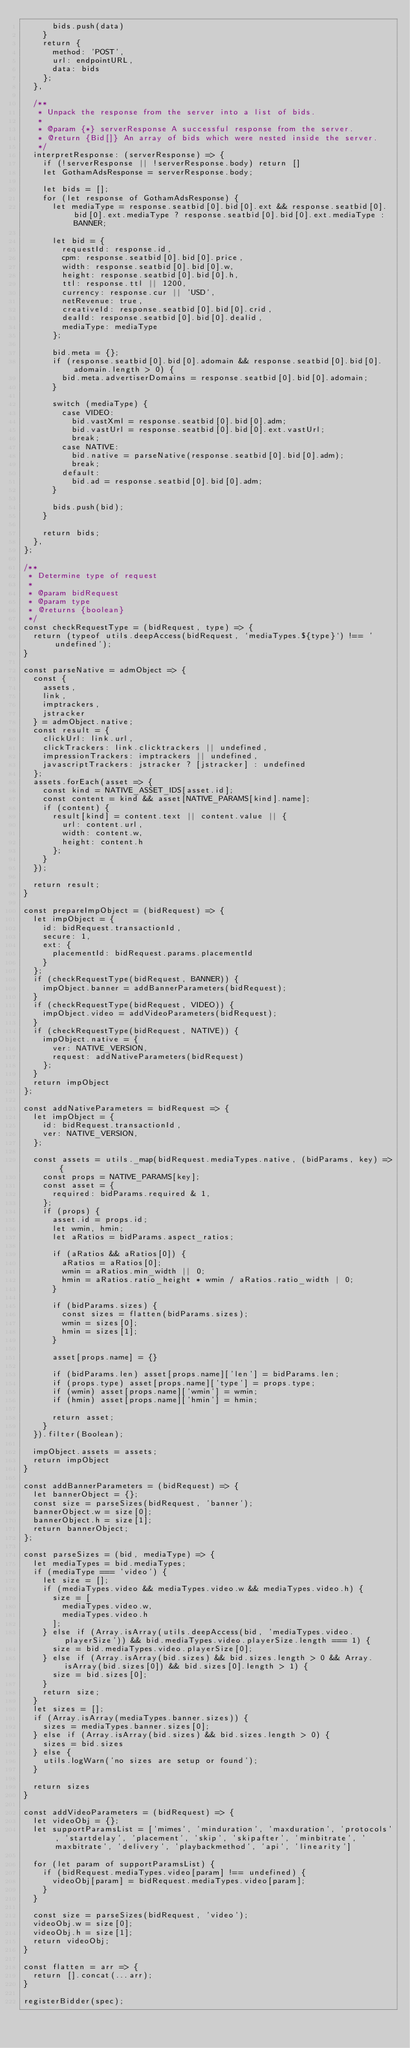Convert code to text. <code><loc_0><loc_0><loc_500><loc_500><_JavaScript_>      bids.push(data)
    }
    return {
      method: 'POST',
      url: endpointURL,
      data: bids
    };
  },

  /**
   * Unpack the response from the server into a list of bids.
   *
   * @param {*} serverResponse A successful response from the server.
   * @return {Bid[]} An array of bids which were nested inside the server.
   */
  interpretResponse: (serverResponse) => {
    if (!serverResponse || !serverResponse.body) return []
    let GothamAdsResponse = serverResponse.body;

    let bids = [];
    for (let response of GothamAdsResponse) {
      let mediaType = response.seatbid[0].bid[0].ext && response.seatbid[0].bid[0].ext.mediaType ? response.seatbid[0].bid[0].ext.mediaType : BANNER;

      let bid = {
        requestId: response.id,
        cpm: response.seatbid[0].bid[0].price,
        width: response.seatbid[0].bid[0].w,
        height: response.seatbid[0].bid[0].h,
        ttl: response.ttl || 1200,
        currency: response.cur || 'USD',
        netRevenue: true,
        creativeId: response.seatbid[0].bid[0].crid,
        dealId: response.seatbid[0].bid[0].dealid,
        mediaType: mediaType
      };

      bid.meta = {};
      if (response.seatbid[0].bid[0].adomain && response.seatbid[0].bid[0].adomain.length > 0) {
        bid.meta.advertiserDomains = response.seatbid[0].bid[0].adomain;
      }

      switch (mediaType) {
        case VIDEO:
          bid.vastXml = response.seatbid[0].bid[0].adm;
          bid.vastUrl = response.seatbid[0].bid[0].ext.vastUrl;
          break;
        case NATIVE:
          bid.native = parseNative(response.seatbid[0].bid[0].adm);
          break;
        default:
          bid.ad = response.seatbid[0].bid[0].adm;
      }

      bids.push(bid);
    }

    return bids;
  },
};

/**
 * Determine type of request
 *
 * @param bidRequest
 * @param type
 * @returns {boolean}
 */
const checkRequestType = (bidRequest, type) => {
  return (typeof utils.deepAccess(bidRequest, `mediaTypes.${type}`) !== 'undefined');
}

const parseNative = admObject => {
  const {
    assets,
    link,
    imptrackers,
    jstracker
  } = admObject.native;
  const result = {
    clickUrl: link.url,
    clickTrackers: link.clicktrackers || undefined,
    impressionTrackers: imptrackers || undefined,
    javascriptTrackers: jstracker ? [jstracker] : undefined
  };
  assets.forEach(asset => {
    const kind = NATIVE_ASSET_IDS[asset.id];
    const content = kind && asset[NATIVE_PARAMS[kind].name];
    if (content) {
      result[kind] = content.text || content.value || {
        url: content.url,
        width: content.w,
        height: content.h
      };
    }
  });

  return result;
}

const prepareImpObject = (bidRequest) => {
  let impObject = {
    id: bidRequest.transactionId,
    secure: 1,
    ext: {
      placementId: bidRequest.params.placementId
    }
  };
  if (checkRequestType(bidRequest, BANNER)) {
    impObject.banner = addBannerParameters(bidRequest);
  }
  if (checkRequestType(bidRequest, VIDEO)) {
    impObject.video = addVideoParameters(bidRequest);
  }
  if (checkRequestType(bidRequest, NATIVE)) {
    impObject.native = {
      ver: NATIVE_VERSION,
      request: addNativeParameters(bidRequest)
    };
  }
  return impObject
};

const addNativeParameters = bidRequest => {
  let impObject = {
    id: bidRequest.transactionId,
    ver: NATIVE_VERSION,
  };

  const assets = utils._map(bidRequest.mediaTypes.native, (bidParams, key) => {
    const props = NATIVE_PARAMS[key];
    const asset = {
      required: bidParams.required & 1,
    };
    if (props) {
      asset.id = props.id;
      let wmin, hmin;
      let aRatios = bidParams.aspect_ratios;

      if (aRatios && aRatios[0]) {
        aRatios = aRatios[0];
        wmin = aRatios.min_width || 0;
        hmin = aRatios.ratio_height * wmin / aRatios.ratio_width | 0;
      }

      if (bidParams.sizes) {
        const sizes = flatten(bidParams.sizes);
        wmin = sizes[0];
        hmin = sizes[1];
      }

      asset[props.name] = {}

      if (bidParams.len) asset[props.name]['len'] = bidParams.len;
      if (props.type) asset[props.name]['type'] = props.type;
      if (wmin) asset[props.name]['wmin'] = wmin;
      if (hmin) asset[props.name]['hmin'] = hmin;

      return asset;
    }
  }).filter(Boolean);

  impObject.assets = assets;
  return impObject
}

const addBannerParameters = (bidRequest) => {
  let bannerObject = {};
  const size = parseSizes(bidRequest, 'banner');
  bannerObject.w = size[0];
  bannerObject.h = size[1];
  return bannerObject;
};

const parseSizes = (bid, mediaType) => {
  let mediaTypes = bid.mediaTypes;
  if (mediaType === 'video') {
    let size = [];
    if (mediaTypes.video && mediaTypes.video.w && mediaTypes.video.h) {
      size = [
        mediaTypes.video.w,
        mediaTypes.video.h
      ];
    } else if (Array.isArray(utils.deepAccess(bid, 'mediaTypes.video.playerSize')) && bid.mediaTypes.video.playerSize.length === 1) {
      size = bid.mediaTypes.video.playerSize[0];
    } else if (Array.isArray(bid.sizes) && bid.sizes.length > 0 && Array.isArray(bid.sizes[0]) && bid.sizes[0].length > 1) {
      size = bid.sizes[0];
    }
    return size;
  }
  let sizes = [];
  if (Array.isArray(mediaTypes.banner.sizes)) {
    sizes = mediaTypes.banner.sizes[0];
  } else if (Array.isArray(bid.sizes) && bid.sizes.length > 0) {
    sizes = bid.sizes
  } else {
    utils.logWarn('no sizes are setup or found');
  }

  return sizes
}

const addVideoParameters = (bidRequest) => {
  let videoObj = {};
  let supportParamsList = ['mimes', 'minduration', 'maxduration', 'protocols', 'startdelay', 'placement', 'skip', 'skipafter', 'minbitrate', 'maxbitrate', 'delivery', 'playbackmethod', 'api', 'linearity']

  for (let param of supportParamsList) {
    if (bidRequest.mediaTypes.video[param] !== undefined) {
      videoObj[param] = bidRequest.mediaTypes.video[param];
    }
  }

  const size = parseSizes(bidRequest, 'video');
  videoObj.w = size[0];
  videoObj.h = size[1];
  return videoObj;
}

const flatten = arr => {
  return [].concat(...arr);
}

registerBidder(spec);
</code> 